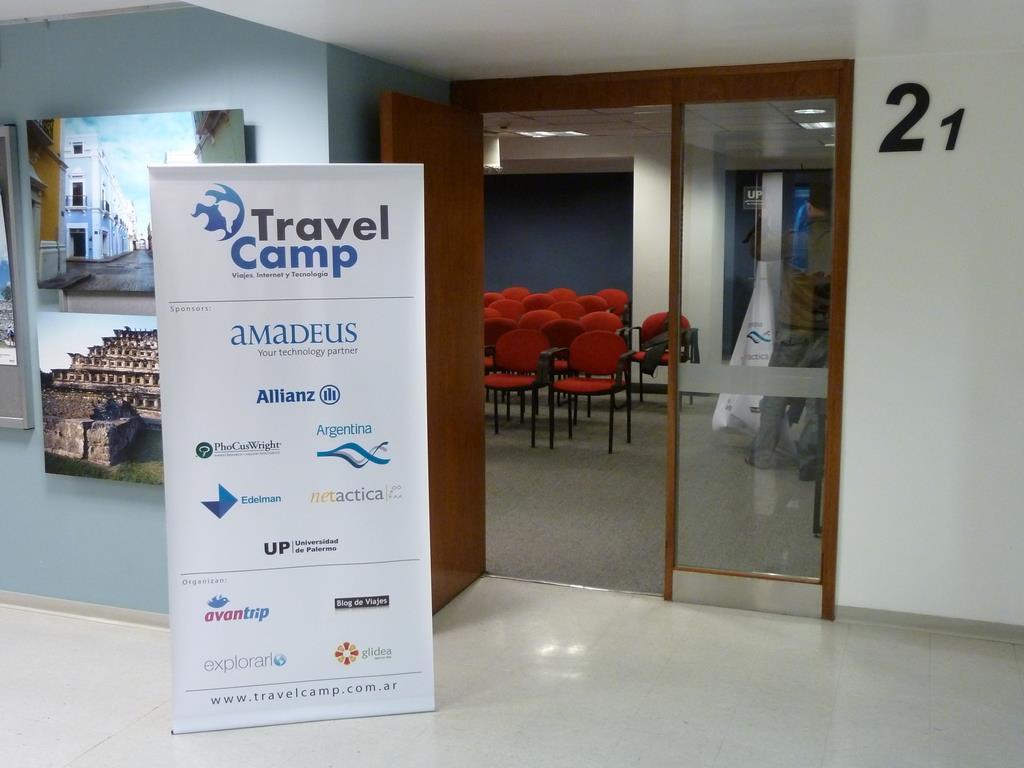Can you describe this image briefly? In the center of the image there is a door and we can see chairs. On the left there is a banner and we can see frames placed on the wall. In the background there is a wall and lights. 